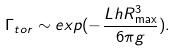<formula> <loc_0><loc_0><loc_500><loc_500>\Gamma _ { t o r } \sim e x p ( - \frac { L h R _ { \max } ^ { 3 } } { 6 \pi g } ) .</formula> 